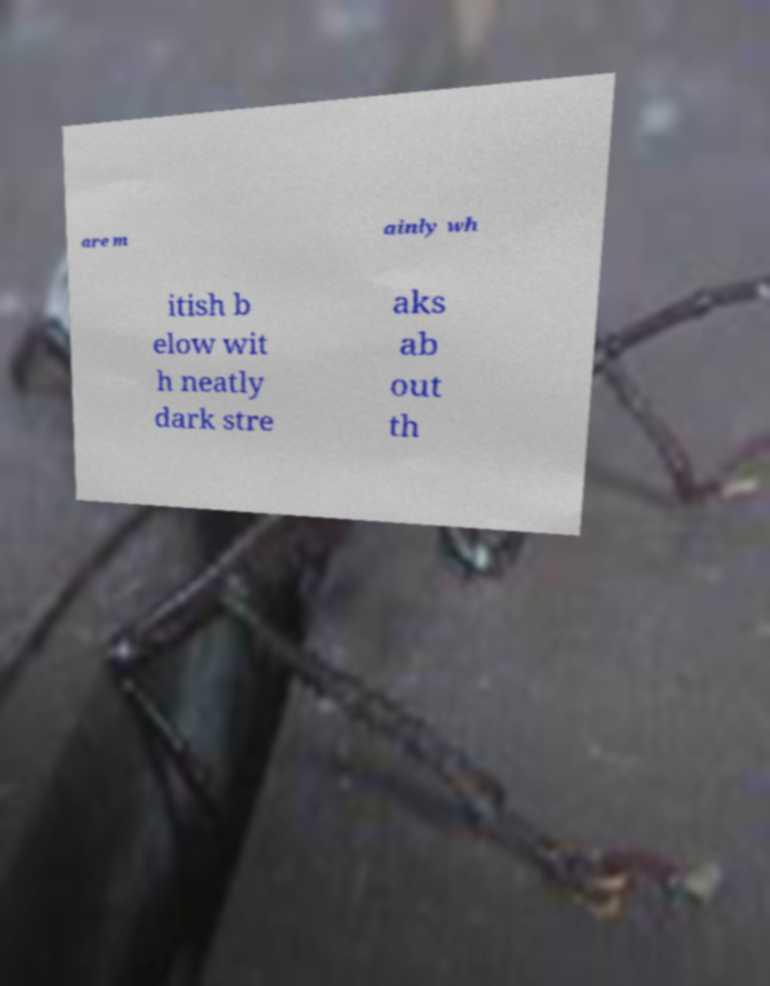For documentation purposes, I need the text within this image transcribed. Could you provide that? are m ainly wh itish b elow wit h neatly dark stre aks ab out th 